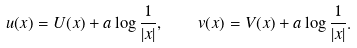Convert formula to latex. <formula><loc_0><loc_0><loc_500><loc_500>u ( x ) = U ( x ) + a \log \frac { 1 } { | x | } , \quad v ( x ) = V ( x ) + a \log \frac { 1 } { | x | } .</formula> 